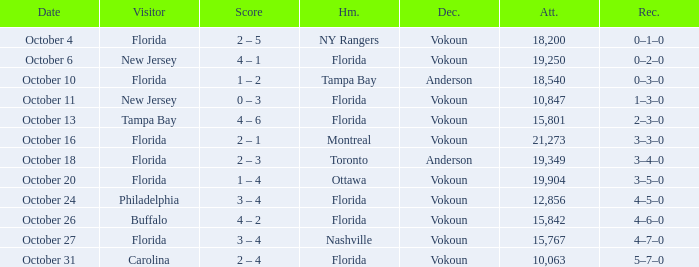Which team was home on October 13? Florida. 